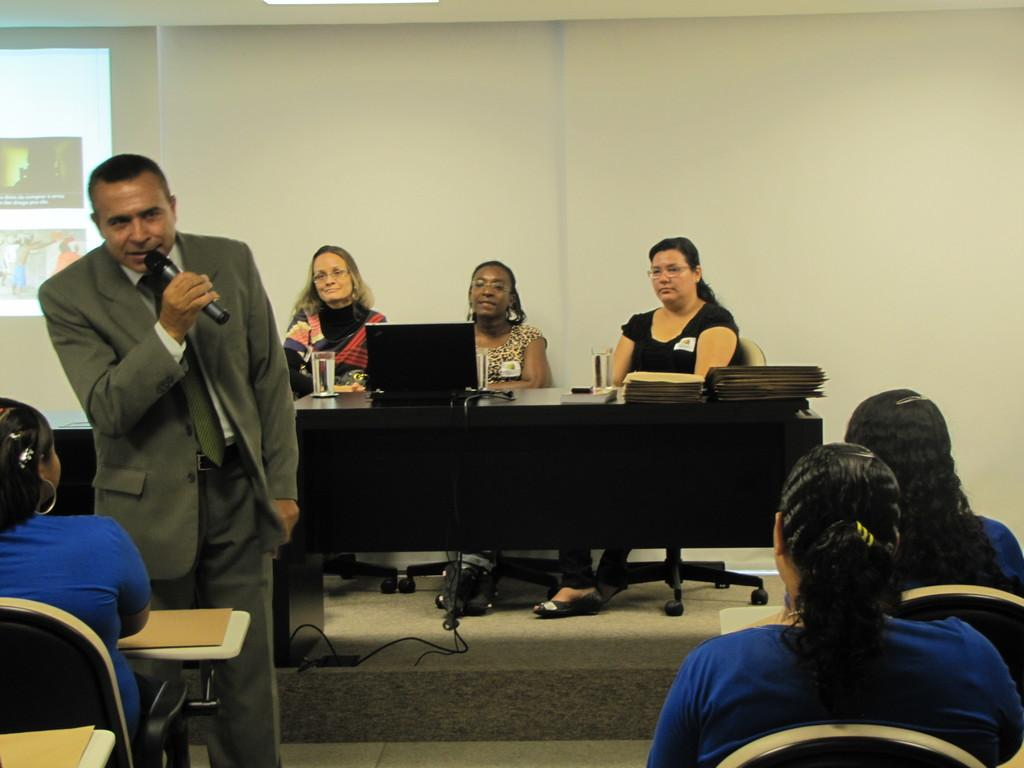What is the person in the image wearing? The person is wearing a suit in the image. What is the person doing in the image? The person is standing and speaking in front of a microphone. Who is the person addressing in the image? The person is addressing a group of people in front of them. What is the seating arrangement behind the person? There are three ladies sitting behind the person. What type of chain is the person wearing in the image? There is no chain visible on the person in the image. 